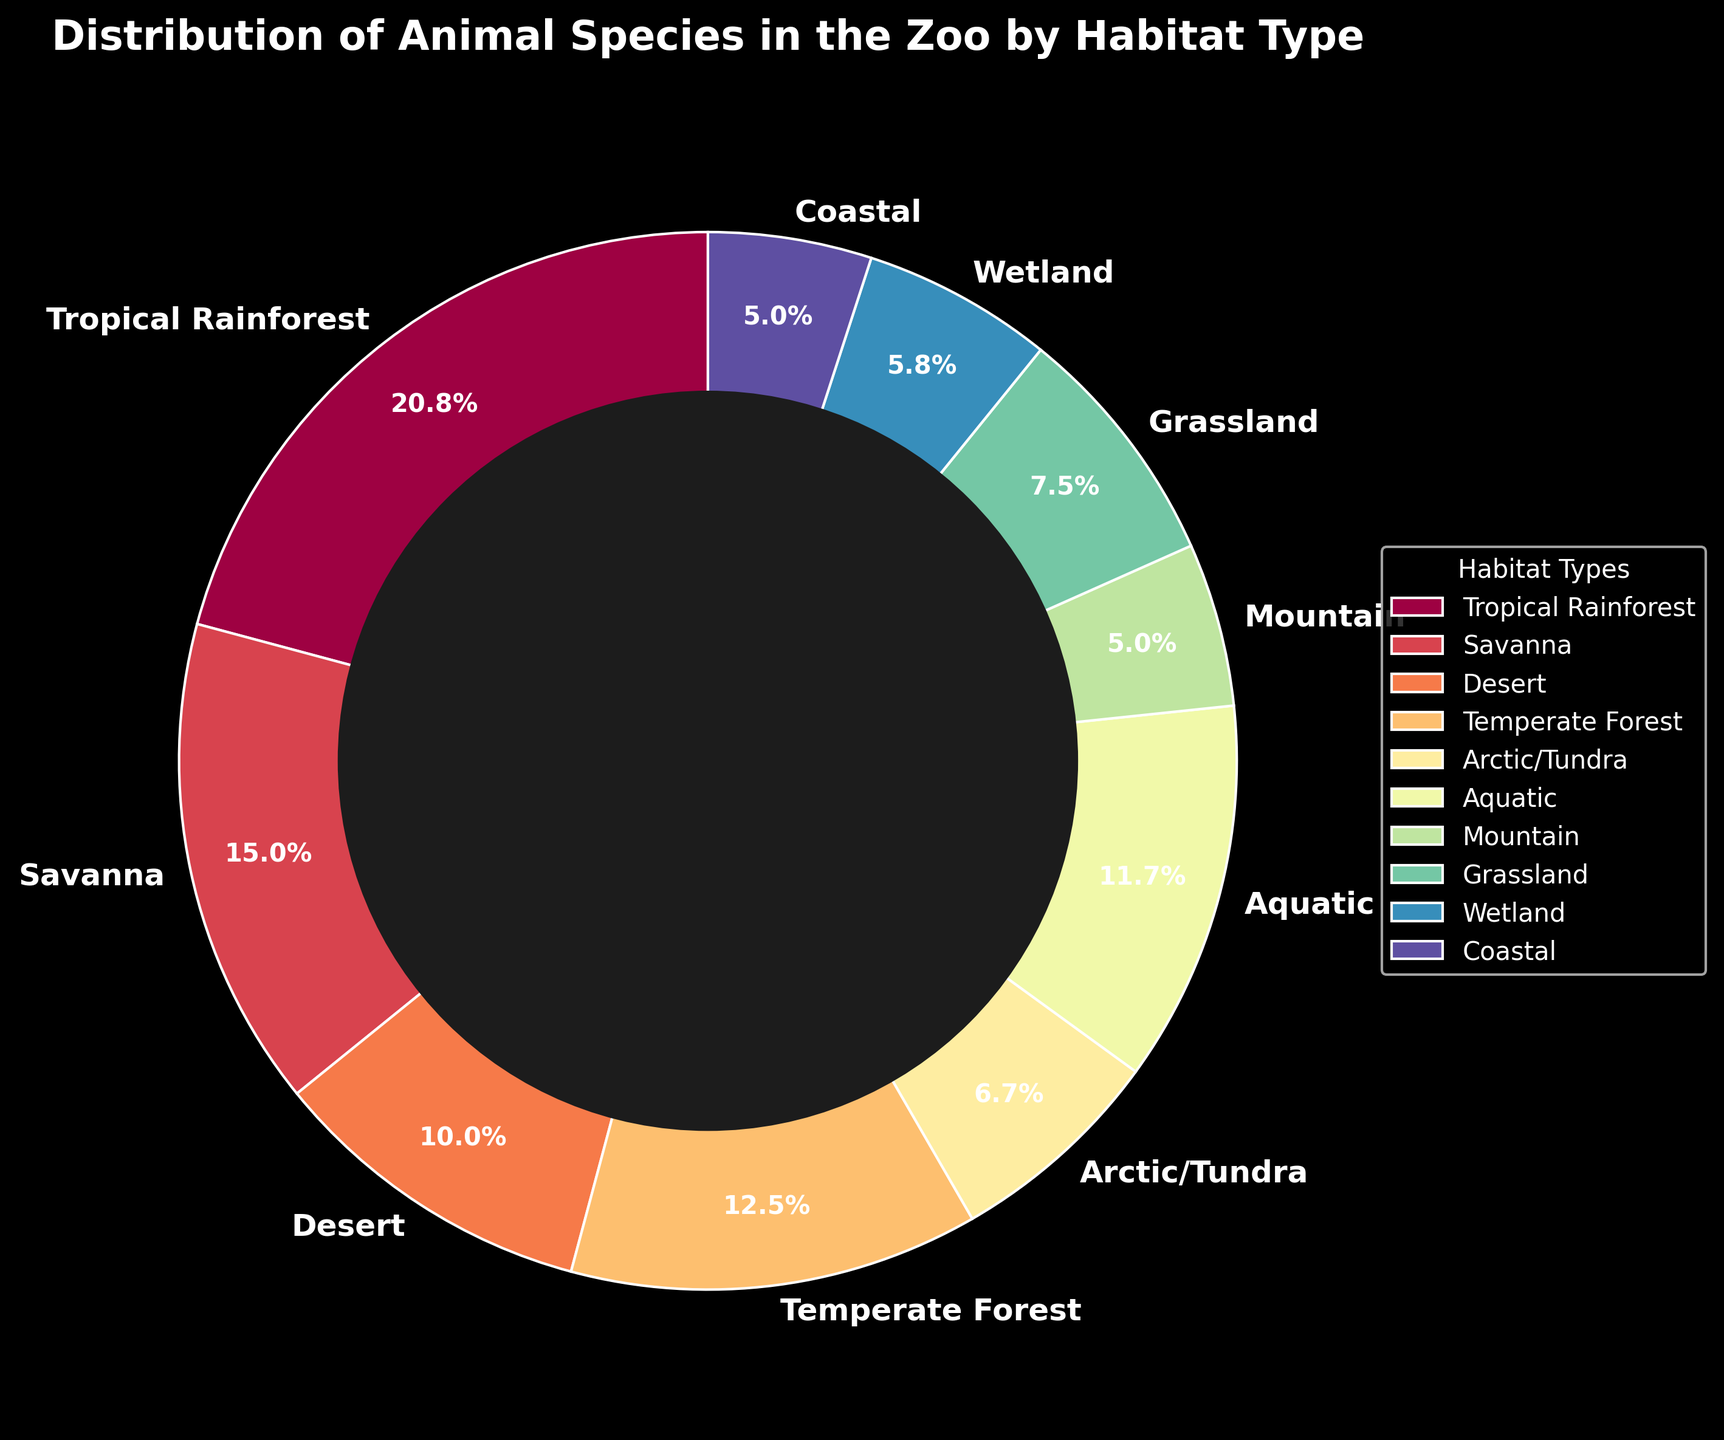What habitat type has the highest percentage of animal species in the zoo? The pie chart shows that Tropical Rainforest has the largest section, occupying 25% of the total distribution.
Answer: Tropical Rainforest Which two habitat types have the same percentage of animal species? The chart shows that Coastal and Mountain both have sections that are equally sized, each representing 6% of the total distribution.
Answer: Coastal and Mountain What is the sum of the percentages for Desert and Grassland habitat types? From the chart, Desert has 12% and Grassland has 9%. Adding them together, we get 12% + 9% = 21%.
Answer: 21% Is the percentage of animal species in Arctic/Tundra greater than in Wetland? The chart shows Arctic/Tundra has 8% and Wetland has 7%. Since 8% is greater than 7%, the percentage is indeed higher in Arctic/Tundra.
Answer: Yes Which habitat type is represented by the lightest colored wedge in the pie chart? The lightest color wedge, as per the custom colormap shading gradient from the code, visually appears to be the section for Arctic/Tundra.
Answer: Arctic/Tundra What is the difference in the percentage between Savanna and Temperate Forest? From the chart, Savanna has 18% and Temperate Forest has 15%. The difference is 18% - 15% = 3%.
Answer: 3% How many habitat types have a percentage of animal species less than 10%? By examining the pie chart, the habitat types are Arctic/Tundra (8%), Mountain (6%), Grassland (9%), Wetland (7%), and Coastal (6%) which are all under 10%. Counting these, there are 5 habitat types.
Answer: 5 What is the total percentage represented by all forest habitat types combined (Tropical Rainforest and Temperate Forest)? The chart shows Tropical Rainforest has 25% and Temperate Forest has 15%. Summing them up, we get 25% + 15% = 40%.
Answer: 40% Which three habitat types combined have a higher total percentage than Tropical Rainforest alone? Savanna (18%), Aquatic (14%), and Temperate Forest (15%) have percentages of 18% + 14% + 15% = 47%, which is greater than Tropical Rainforest’s 25%.
Answer: Savanna, Aquatic, Temperate Forest 